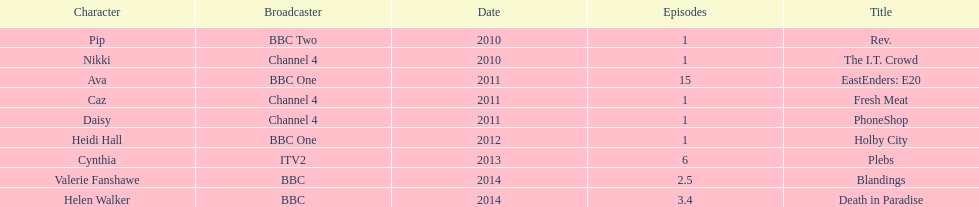What is the only role she played with broadcaster itv2? Cynthia. 